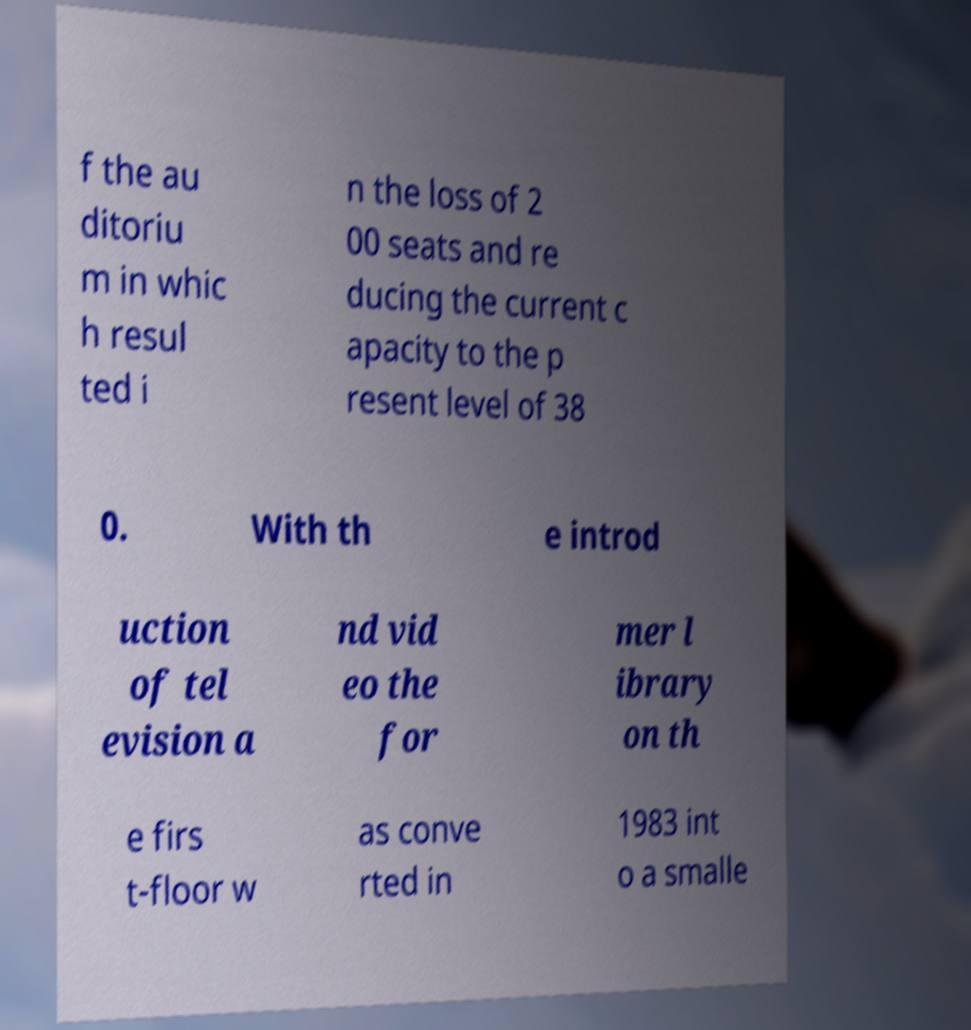Please read and relay the text visible in this image. What does it say? f the au ditoriu m in whic h resul ted i n the loss of 2 00 seats and re ducing the current c apacity to the p resent level of 38 0. With th e introd uction of tel evision a nd vid eo the for mer l ibrary on th e firs t-floor w as conve rted in 1983 int o a smalle 